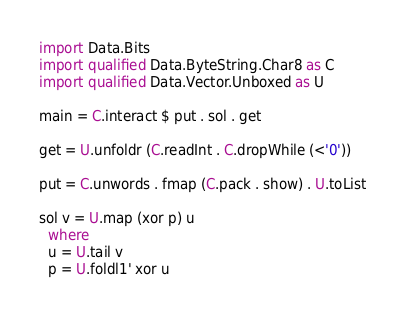Convert code to text. <code><loc_0><loc_0><loc_500><loc_500><_Haskell_>import Data.Bits
import qualified Data.ByteString.Char8 as C
import qualified Data.Vector.Unboxed as U

main = C.interact $ put . sol . get

get = U.unfoldr (C.readInt . C.dropWhile (<'0'))

put = C.unwords . fmap (C.pack . show) . U.toList

sol v = U.map (xor p) u
  where
  u = U.tail v
  p = U.foldl1' xor u</code> 